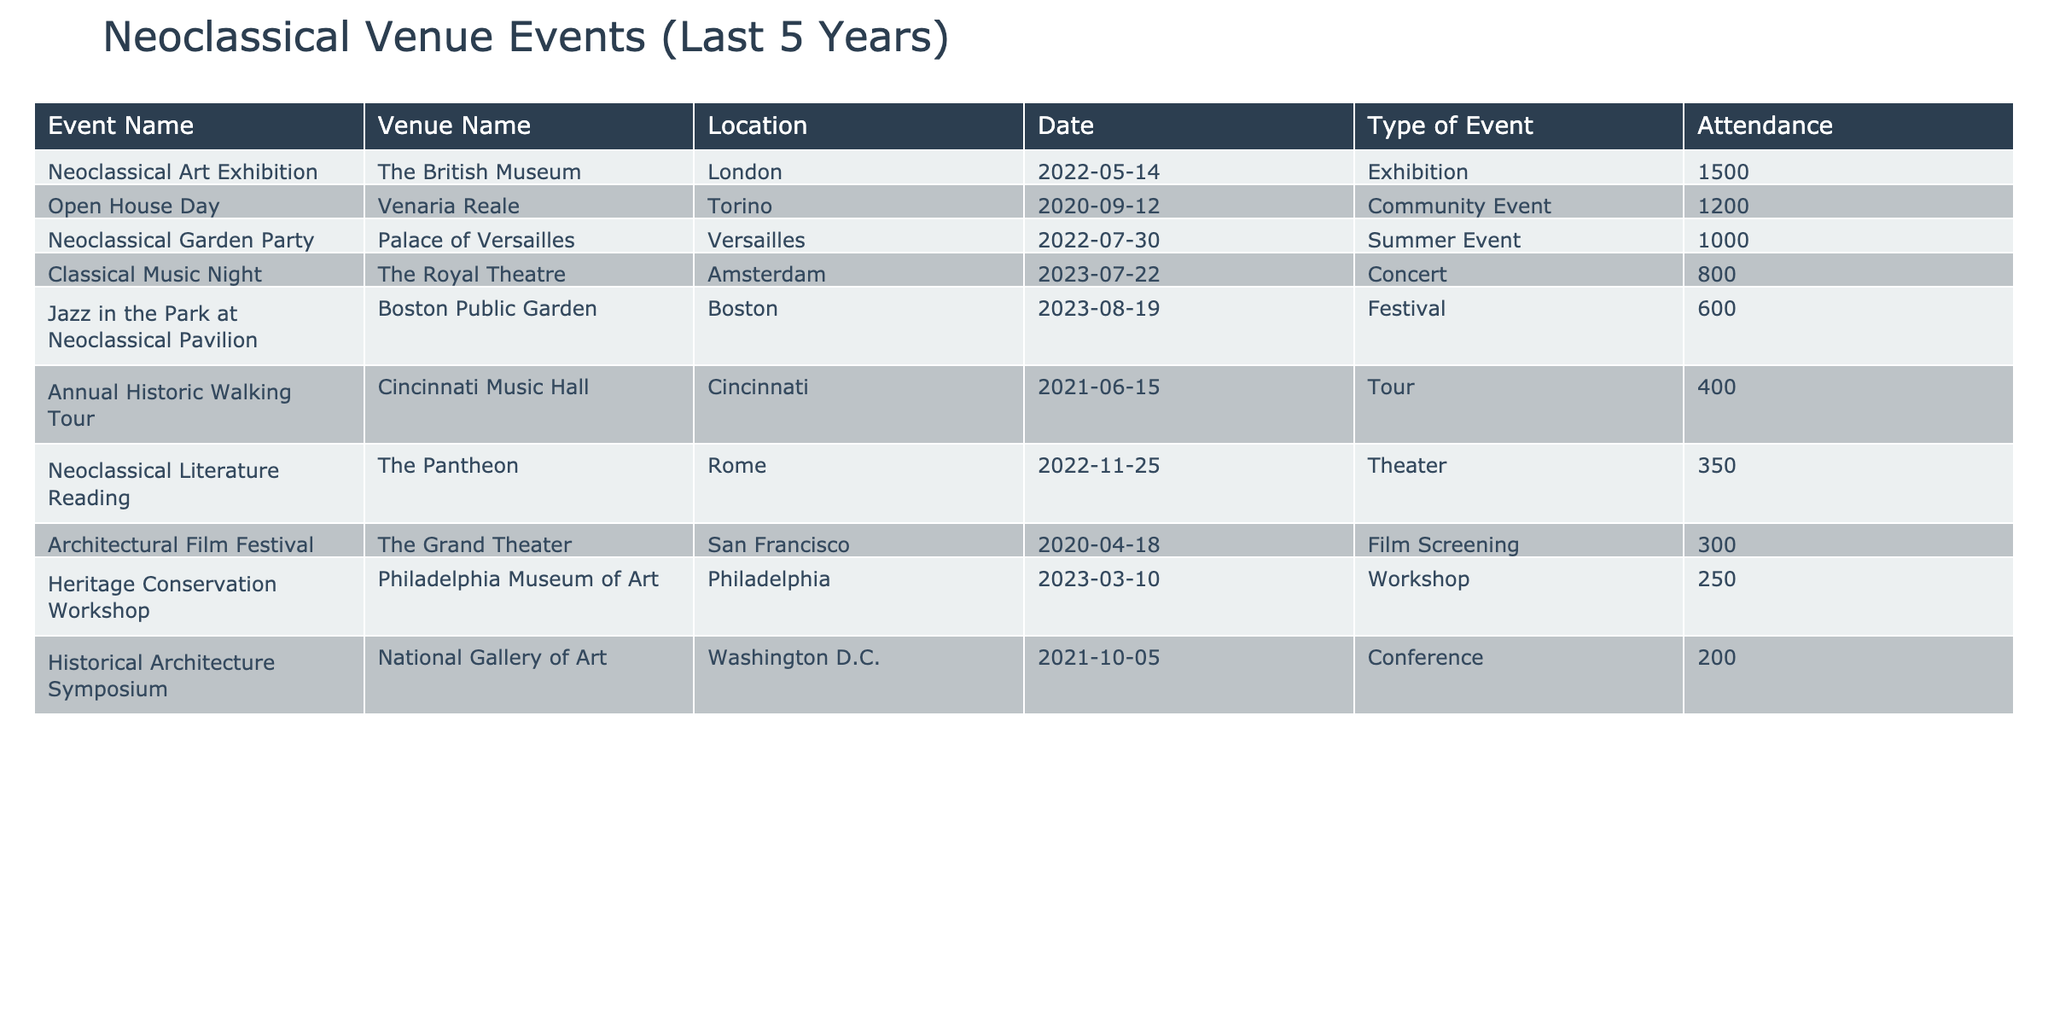What was the highest attendance at a neoclassical venue event? The table shows the attendance figures for each event. Scanning the "Attendance" column, the highest value is 1500 for the "Neoclassical Art Exhibition" at The British Museum.
Answer: 1500 Which event had the least attendance? By reviewing the "Attendance" column, we see that the lowest attendance figure is 250 for the "Heritage Conservation Workshop" at the Philadelphia Museum of Art.
Answer: 250 How many events were held in 2022? Looking at the "Date" column and counting the events that occurred in 2022—three events are listed: the "Neoclassical Art Exhibition," the "Neoclassical Literature Reading," and the "Neoclassical Garden Party."
Answer: 3 What is the average attendance of all events listed in the table? To find the average, sum the attendances: 1500 + 800 + 200 + 1200 + 250 + 350 + 400 + 600 + 300 + 1000 = 5050. Then divide by the number of events (10): 5050 / 10 = 505.
Answer: 505 Did any of the events take place in a location named "Boston"? Checking the "Location" column, we can see that "Boston" appears for "Jazz in the Park at Neoclassical Pavilion," confirming that yes, an event took place in Boston.
Answer: Yes Which type of event had the highest attendance, and what was that attendance? Filtering the "Type of Event" and looking for the highest attendance, the exhibition type shows the highest attendance of 1500 for the "Neoclassical Art Exhibition."
Answer: Exhibition, 1500 How many events held in 2021 had an attendance greater than 300? Examining the table for 2021 events: the "Historical Architecture Symposium" (200) and "Annual Historic Walking Tour" (400). Only the "Annual Historic Walking Tour" exceeds 300. Therefore, there is one such event.
Answer: 1 Which venue hosted the most events in the last five years? By reviewing the table for event counts by venue, we see that venues like The British Museum and the Royal Theatre only hosted one event each. Further counting reveals no venue hosted more than one event in this data.
Answer: No venue hosted more than one event What is the total attendance at events held in 2020? Looking specifically at events from 2020, we have the "Open House Day" (1200) and "Architectural Film Festival" (300). The total attendance thus is 1200 + 300 = 1500.
Answer: 1500 